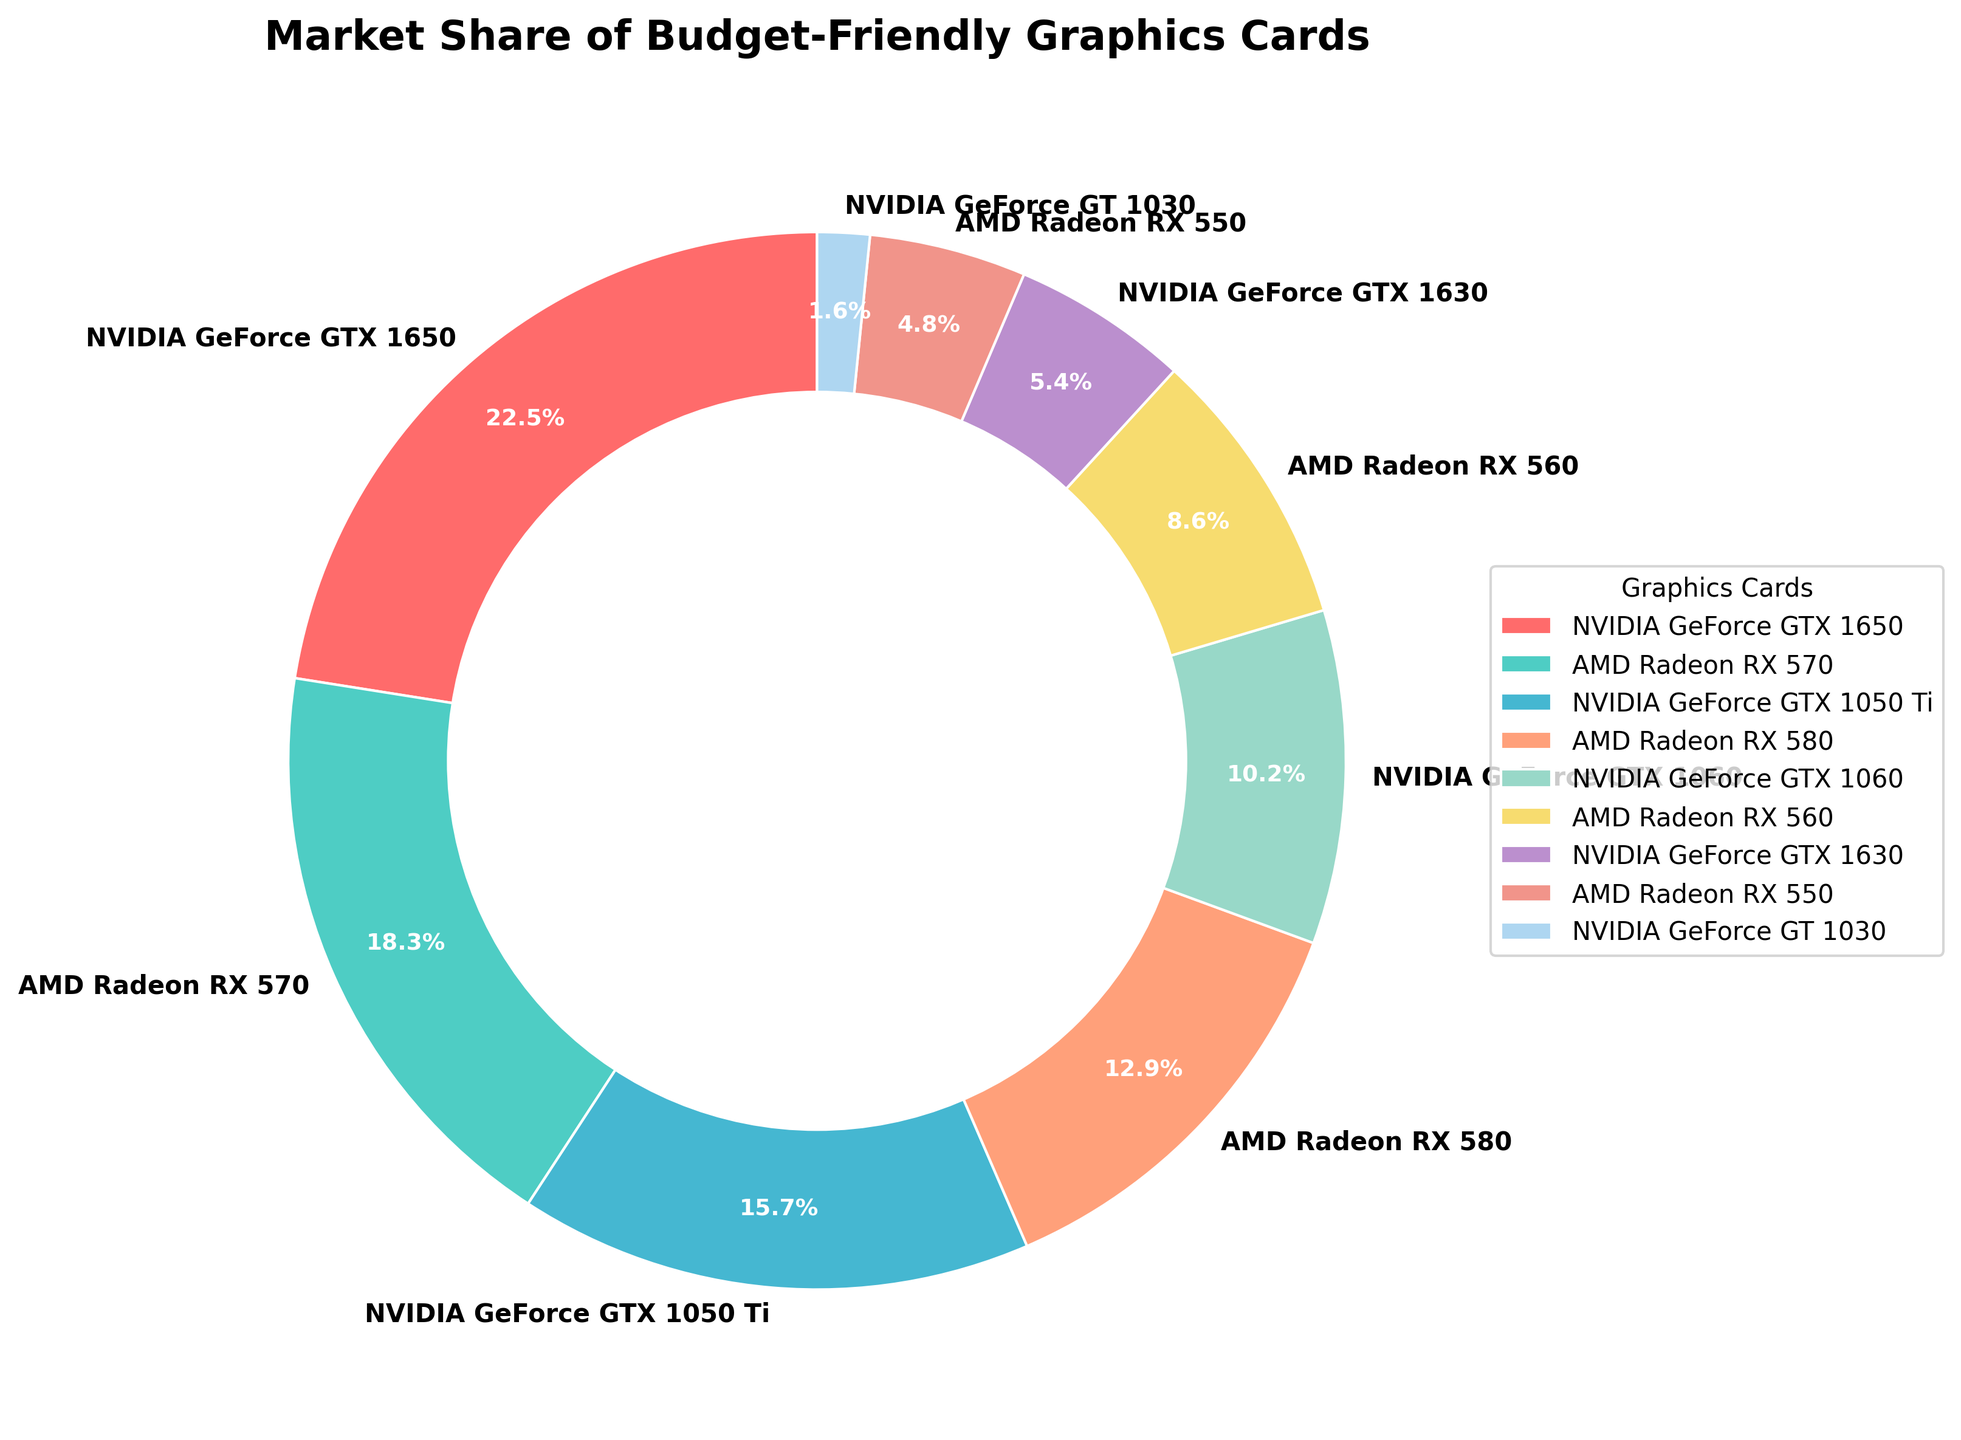What budget-friendly graphics card has the largest market share? To answer this, look at the segment with the largest percentage. The NVIDIA GeForce GTX 1650 has the largest market share shown on the pie chart at 22.5%.
Answer: NVIDIA GeForce GTX 1650 Which graphics card from AMD has the smallest market share? Find the AMD graphics card with the smallest percentage from the chart. The AMD Radeon RX 550 has the smallest market share at 4.8%.
Answer: AMD Radeon RX 550 What is the combined market share of the NVIDIA GeForce GTX 1650 and AMD Radeon RX 570? Add the market shares of these two graphics cards (22.5 + 18.3). The combined market share is 40.8%.
Answer: 40.8% Which graphics card has a larger market share: NVIDIA GeForce GTX 1050 Ti or AMD Radeon RX 580? Compare the market shares of the two cards. The NVIDIA GeForce GTX 1050 Ti has a market share of 15.7%, while the AMD Radeon RX 580 has a market share of 12.9%. Therefore, the NVIDIA GeForce GTX 1050 Ti has a larger market share.
Answer: NVIDIA GeForce GTX 1050 Ti Calculate the difference in market share between the NVIDIA GeForce GTX 1060 and NVIDIA GeForce GT 1030. Subtract the market share of the NVIDIA GeForce GT 1030 from the NVIDIA GeForce GTX 1060 (10.2 - 1.6). The difference is 8.6%.
Answer: 8.6% What is the average market share of the AMD graphics cards shown in the chart? Add the market shares of all AMD graphics cards and divide by the number of AMD cards (18.3 + 12.9 + 8.6 + 4.8) / 4. The average is 11.15%.
Answer: 11.15% Identify the graphics card with the turquoise color and its market share. The turquoise color indicates the AMD Radeon RX 570, which has a market share of 18.3%.
Answer: AMD Radeon RX 570, 18.3% Which graphics card's segment has the smallest visual slice in the pie chart, and what is its market share? The smallest slice belongs to the NVIDIA GeForce GT 1030 with a market share of 1.6%.
Answer: NVIDIA GeForce GT 1030, 1.6% How much larger is the market share of the AMD Radeon RX 580 compared to the NVIDIA GeForce GT 1030? Subtract the market share of the NVIDIA GeForce GT 1030 from the AMD Radeon RX 580 (12.9 - 1.6). The difference is 11.3%.
Answer: 11.3% What is the combined market share of all NVIDIA graphics cards mentioned in the chart? Add the market shares of all NVIDIA graphics cards (22.5 + 15.7 + 10.2 + 5.4 + 1.6). The combined market share is 55.4%.
Answer: 55.4% 